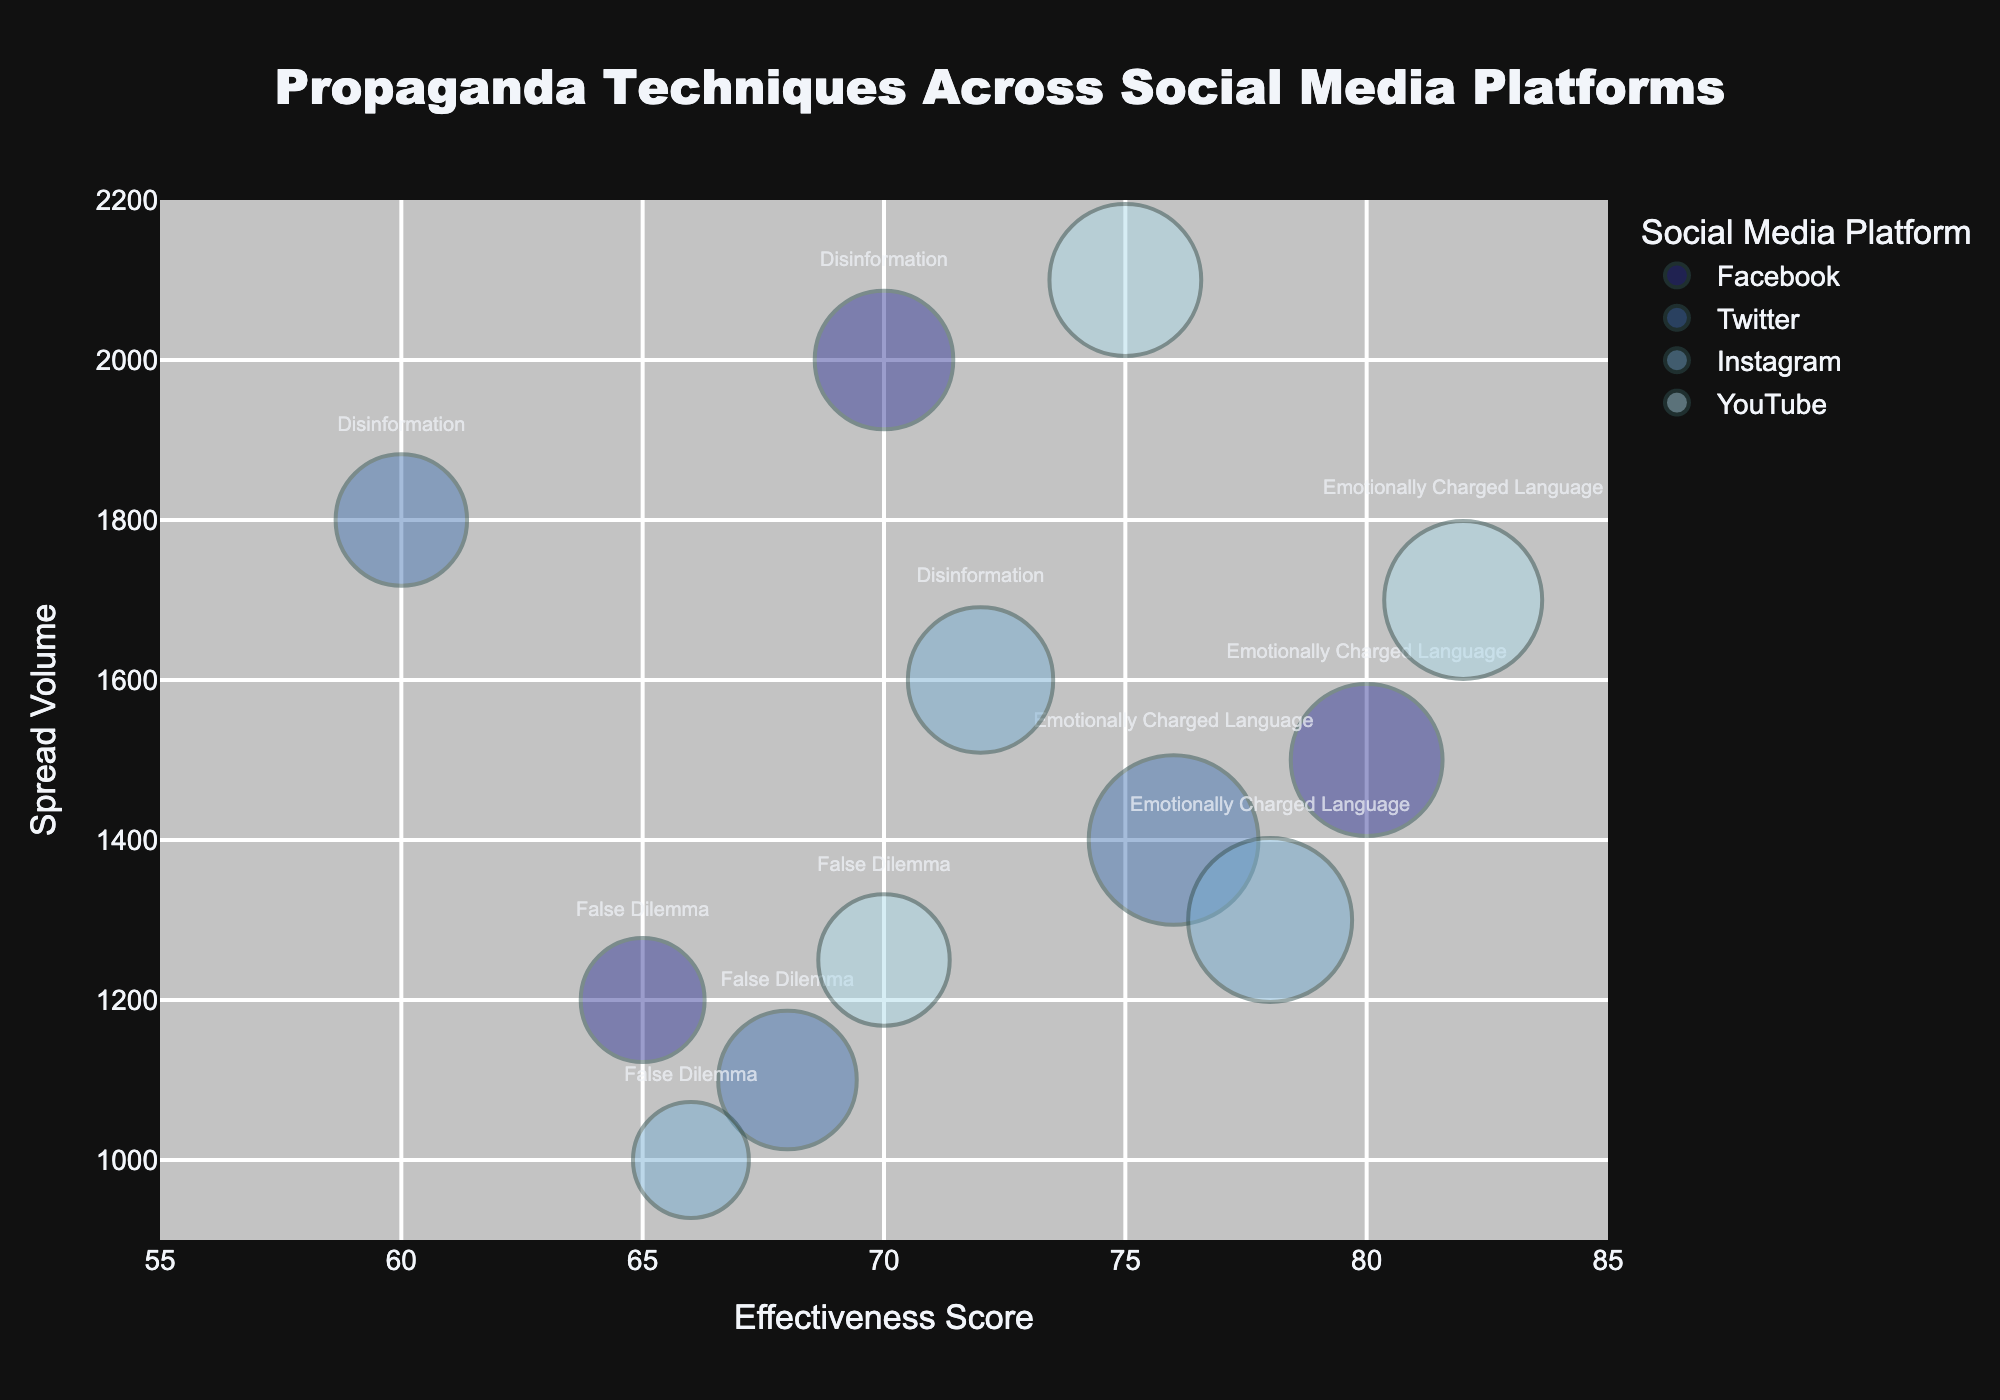What is the title of the figure? The title of the figure is prominently displayed at the top and reads "Propaganda Techniques Across Social Media Platforms".
Answer: Propaganda Techniques Across Social Media Platforms Which social media platform has the highest effectiveness score for "Disinformation"? By observing the positions of the bubbles along the Effectiveness Score axis, you can see that YouTube's "Disinformation" bubble has the highest effectiveness score.
Answer: YouTube Which propaganda technique has the largest spread volume on Instagram? Look at the Spread Volume axis and compare the position of the bubbles for Instagram. The "Disinformation" technique has the highest spread volume on Instagram.
Answer: Disinformation What is the average effectiveness score of the propaganda techniques on Twitter? The effectiveness scores for Twitter are 76, 60, and 68. Add these scores (76 + 60 + 68 = 204) and then divide by 3.
Answer: 68 Which platform has the bubble with the largest size? The size of the bubbles relates to the Engagement Rate. By comparing the sizes, Twitter has the bubble with the largest size, which corresponds to "Emotionally Charged Language".
Answer: Twitter Which technique on Facebook has the lowest engagement rate, and what is it? Comparing the sizes of the bubbles on Facebook, the "False Dilemma" bubble is the smallest, indicating the lowest engagement rate.
Answer: False Dilemma, 0.08 How many social media platforms have an effectiveness score of 70 or more for "Disinformation"? By looking at the effectiveness scores along the x-axis for the "Disinformation" bubbles, we count those with scores of 70 or more. Facebook (70) and YouTube (75) meet this criterion.
Answer: 2 On which platform is the "Emotionally Charged Language" technique the most engaging? Engagement Rate is represented by bubble size. Comparing the size of "Emotionally Charged Language" bubbles, Twitter’s bubble is largest, indicating the highest engagement rate.
Answer: Twitter What is the range of spread volumes for "False Dilemma" across all platforms? Look at the positions of the "False Dilemma" bubbles along the Spread Volume axis. The minimum spread volume is 1000 (Instagram), and the maximum spread volume is 1250 (YouTube).
Answer: 1000 to 1250 Which social media platform has the most data points, and how many? Count all the bubbles colored by each social media platform. Each platform has three bubbles, so all platforms have an equal number of data points.
Answer: Equal, 3 each 